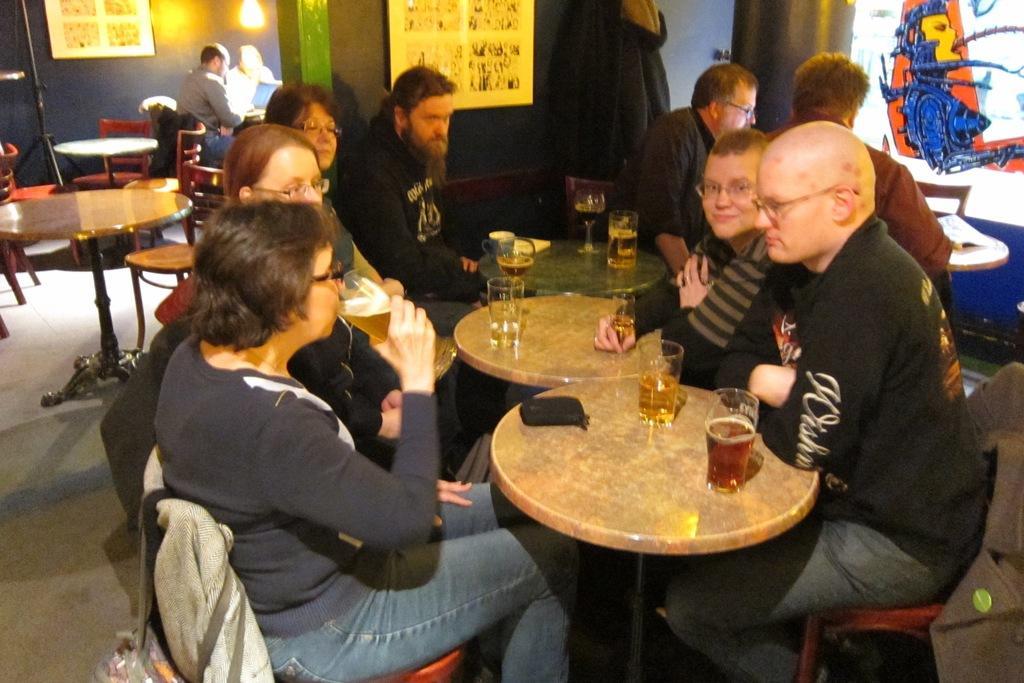Could you give a brief overview of what you see in this image? In this image, a group of people sitting on the chair in front of the table on which wine glasses are kept. A background wall is purple in color on which wall painting is there. A pillar is purple in color. It looks as if the image is taken inside a bar. 